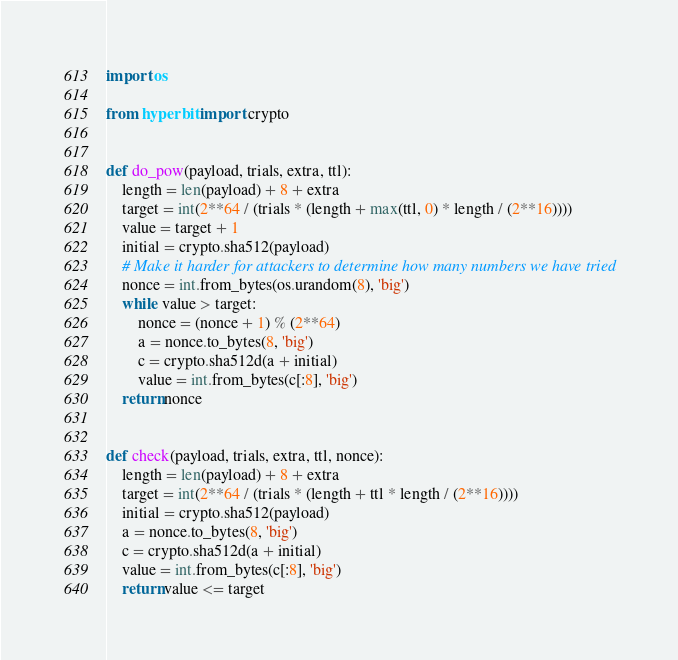Convert code to text. <code><loc_0><loc_0><loc_500><loc_500><_Python_>
import os

from hyperbit import crypto


def do_pow(payload, trials, extra, ttl):
    length = len(payload) + 8 + extra
    target = int(2**64 / (trials * (length + max(ttl, 0) * length / (2**16))))
    value = target + 1
    initial = crypto.sha512(payload)
    # Make it harder for attackers to determine how many numbers we have tried
    nonce = int.from_bytes(os.urandom(8), 'big')
    while value > target:
        nonce = (nonce + 1) % (2**64)
        a = nonce.to_bytes(8, 'big')
        c = crypto.sha512d(a + initial)
        value = int.from_bytes(c[:8], 'big')
    return nonce


def check(payload, trials, extra, ttl, nonce):
    length = len(payload) + 8 + extra
    target = int(2**64 / (trials * (length + ttl * length / (2**16))))
    initial = crypto.sha512(payload)
    a = nonce.to_bytes(8, 'big')
    c = crypto.sha512d(a + initial)
    value = int.from_bytes(c[:8], 'big')
    return value <= target
</code> 